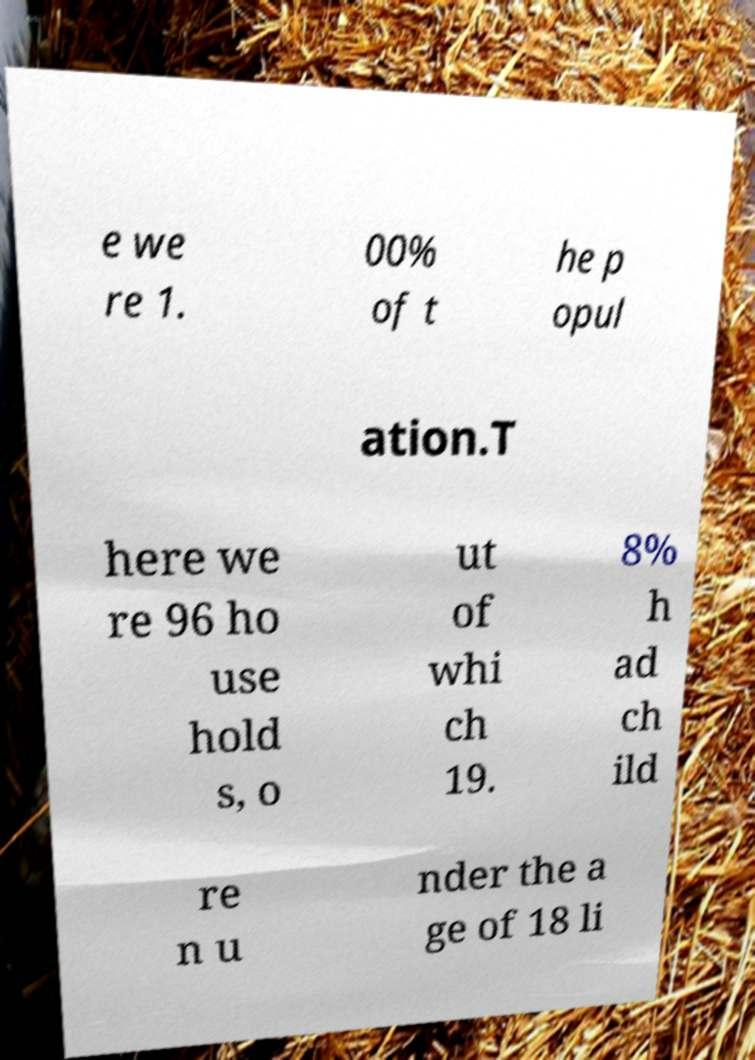Can you read and provide the text displayed in the image?This photo seems to have some interesting text. Can you extract and type it out for me? e we re 1. 00% of t he p opul ation.T here we re 96 ho use hold s, o ut of whi ch 19. 8% h ad ch ild re n u nder the a ge of 18 li 